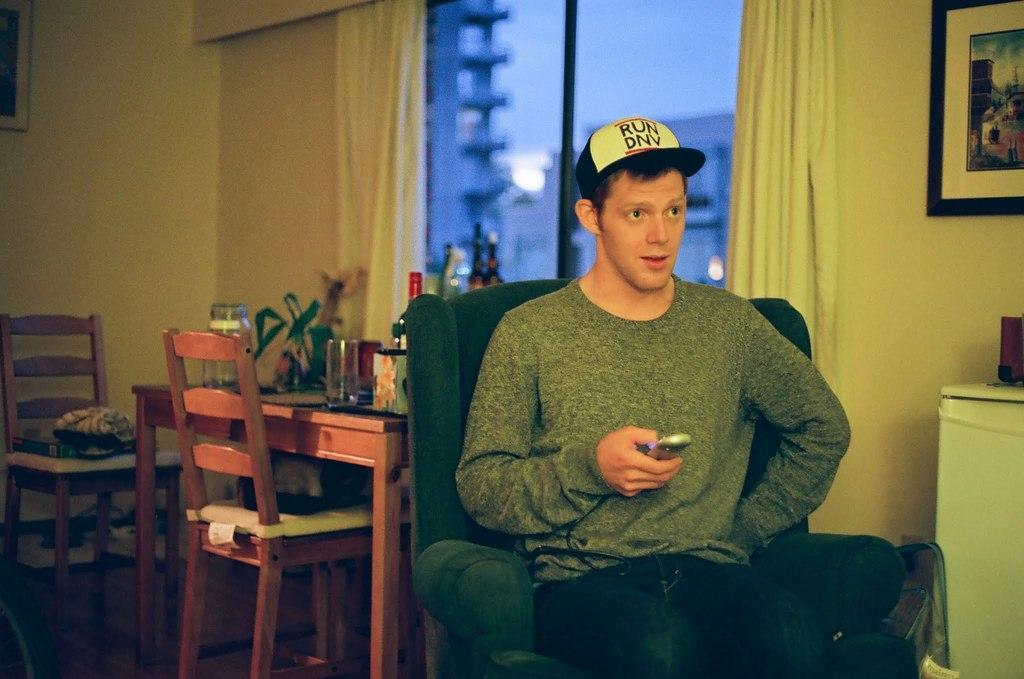Could you give a brief overview of what you see in this image? This person sitting on the chair and holding remote and wear cap,behind this person we can see table,chair,wall,screen,curtains,glass window,frames,on the table there are glasses,bottles,jar. From this glass window we can see sky. 